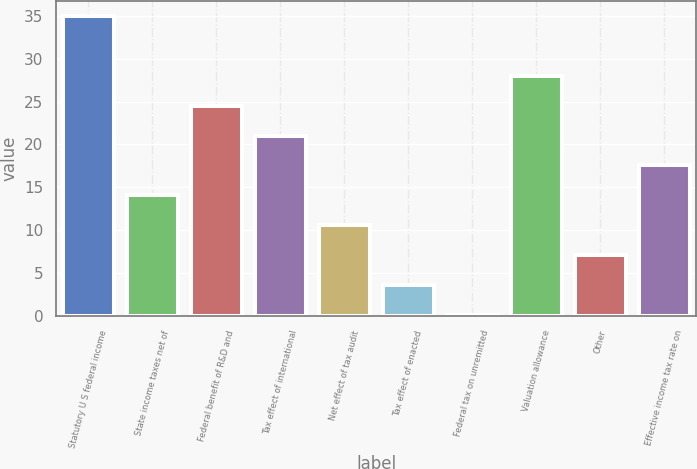<chart> <loc_0><loc_0><loc_500><loc_500><bar_chart><fcel>Statutory U S federal income<fcel>State income taxes net of<fcel>Federal benefit of R&D and<fcel>Tax effect of international<fcel>Net effect of tax audit<fcel>Tax effect of enacted<fcel>Federal tax on unremitted<fcel>Valuation allowance<fcel>Other<fcel>Effective income tax rate on<nl><fcel>35<fcel>14.06<fcel>24.53<fcel>21.04<fcel>10.57<fcel>3.59<fcel>0.1<fcel>28.02<fcel>7.08<fcel>17.55<nl></chart> 